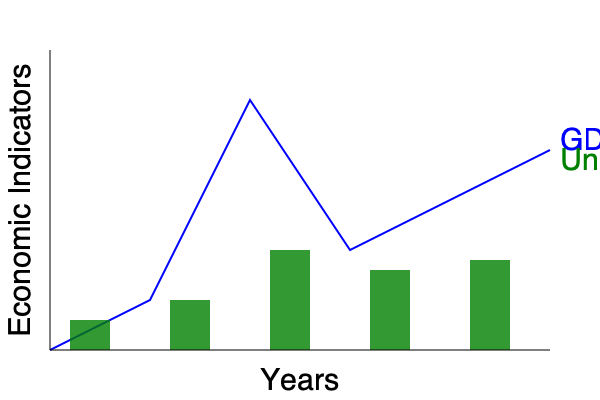Based on the graph showing GDP (blue line) and unemployment rates (green bars) over time in a war-affected country, what economic phenomenon is likely occurring between the second and third data points, and how might this relate to the conflict's impact on the economy? To answer this question, let's analyze the graph step-by-step:

1. Observe the GDP trend (blue line):
   - From the second to the third data point, there's a sharp increase in GDP.

2. Examine the unemployment rates (green bars):
   - The unemployment rate also increases significantly from the second to the third data point.

3. Consider the economic implications:
   - Usually, an increase in GDP is associated with a decrease in unemployment (inverse relationship).
   - However, in this case, both GDP and unemployment are rising simultaneously.

4. Relate to the context of war:
   - This unusual pattern could be explained by a war economy phenomenon.
   - During wartime, there's often increased government spending on military and defense.
   - This can lead to a rise in GDP due to increased production of war-related goods and services.

5. Understand the impact on employment:
   - Despite the GDP increase, unemployment rises because:
     a) Many civilian industries may be disrupted or destroyed by the conflict.
     b) There's a shift in the labor market towards military-related jobs, leaving many civilians unemployed.

6. Conclusion:
   - The phenomenon occurring is likely the transition to a war economy.
   - This demonstrates how conflict can create economic growth in specific sectors while simultaneously causing widespread unemployment and economic disruption in others.
Answer: Transition to a war economy 